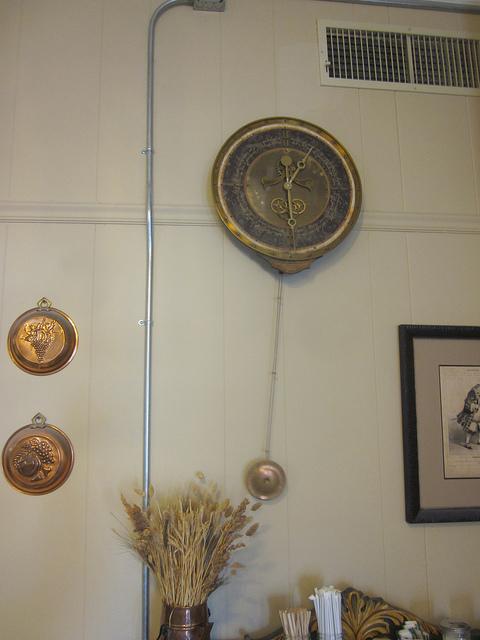What time is it?
Answer briefly. 1:30. Has the wood-paneling been painted?
Answer briefly. Yes. Where is the clock?
Concise answer only. Wall. 